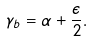Convert formula to latex. <formula><loc_0><loc_0><loc_500><loc_500>\gamma _ { b } = \alpha + \frac { \epsilon } { 2 } .</formula> 